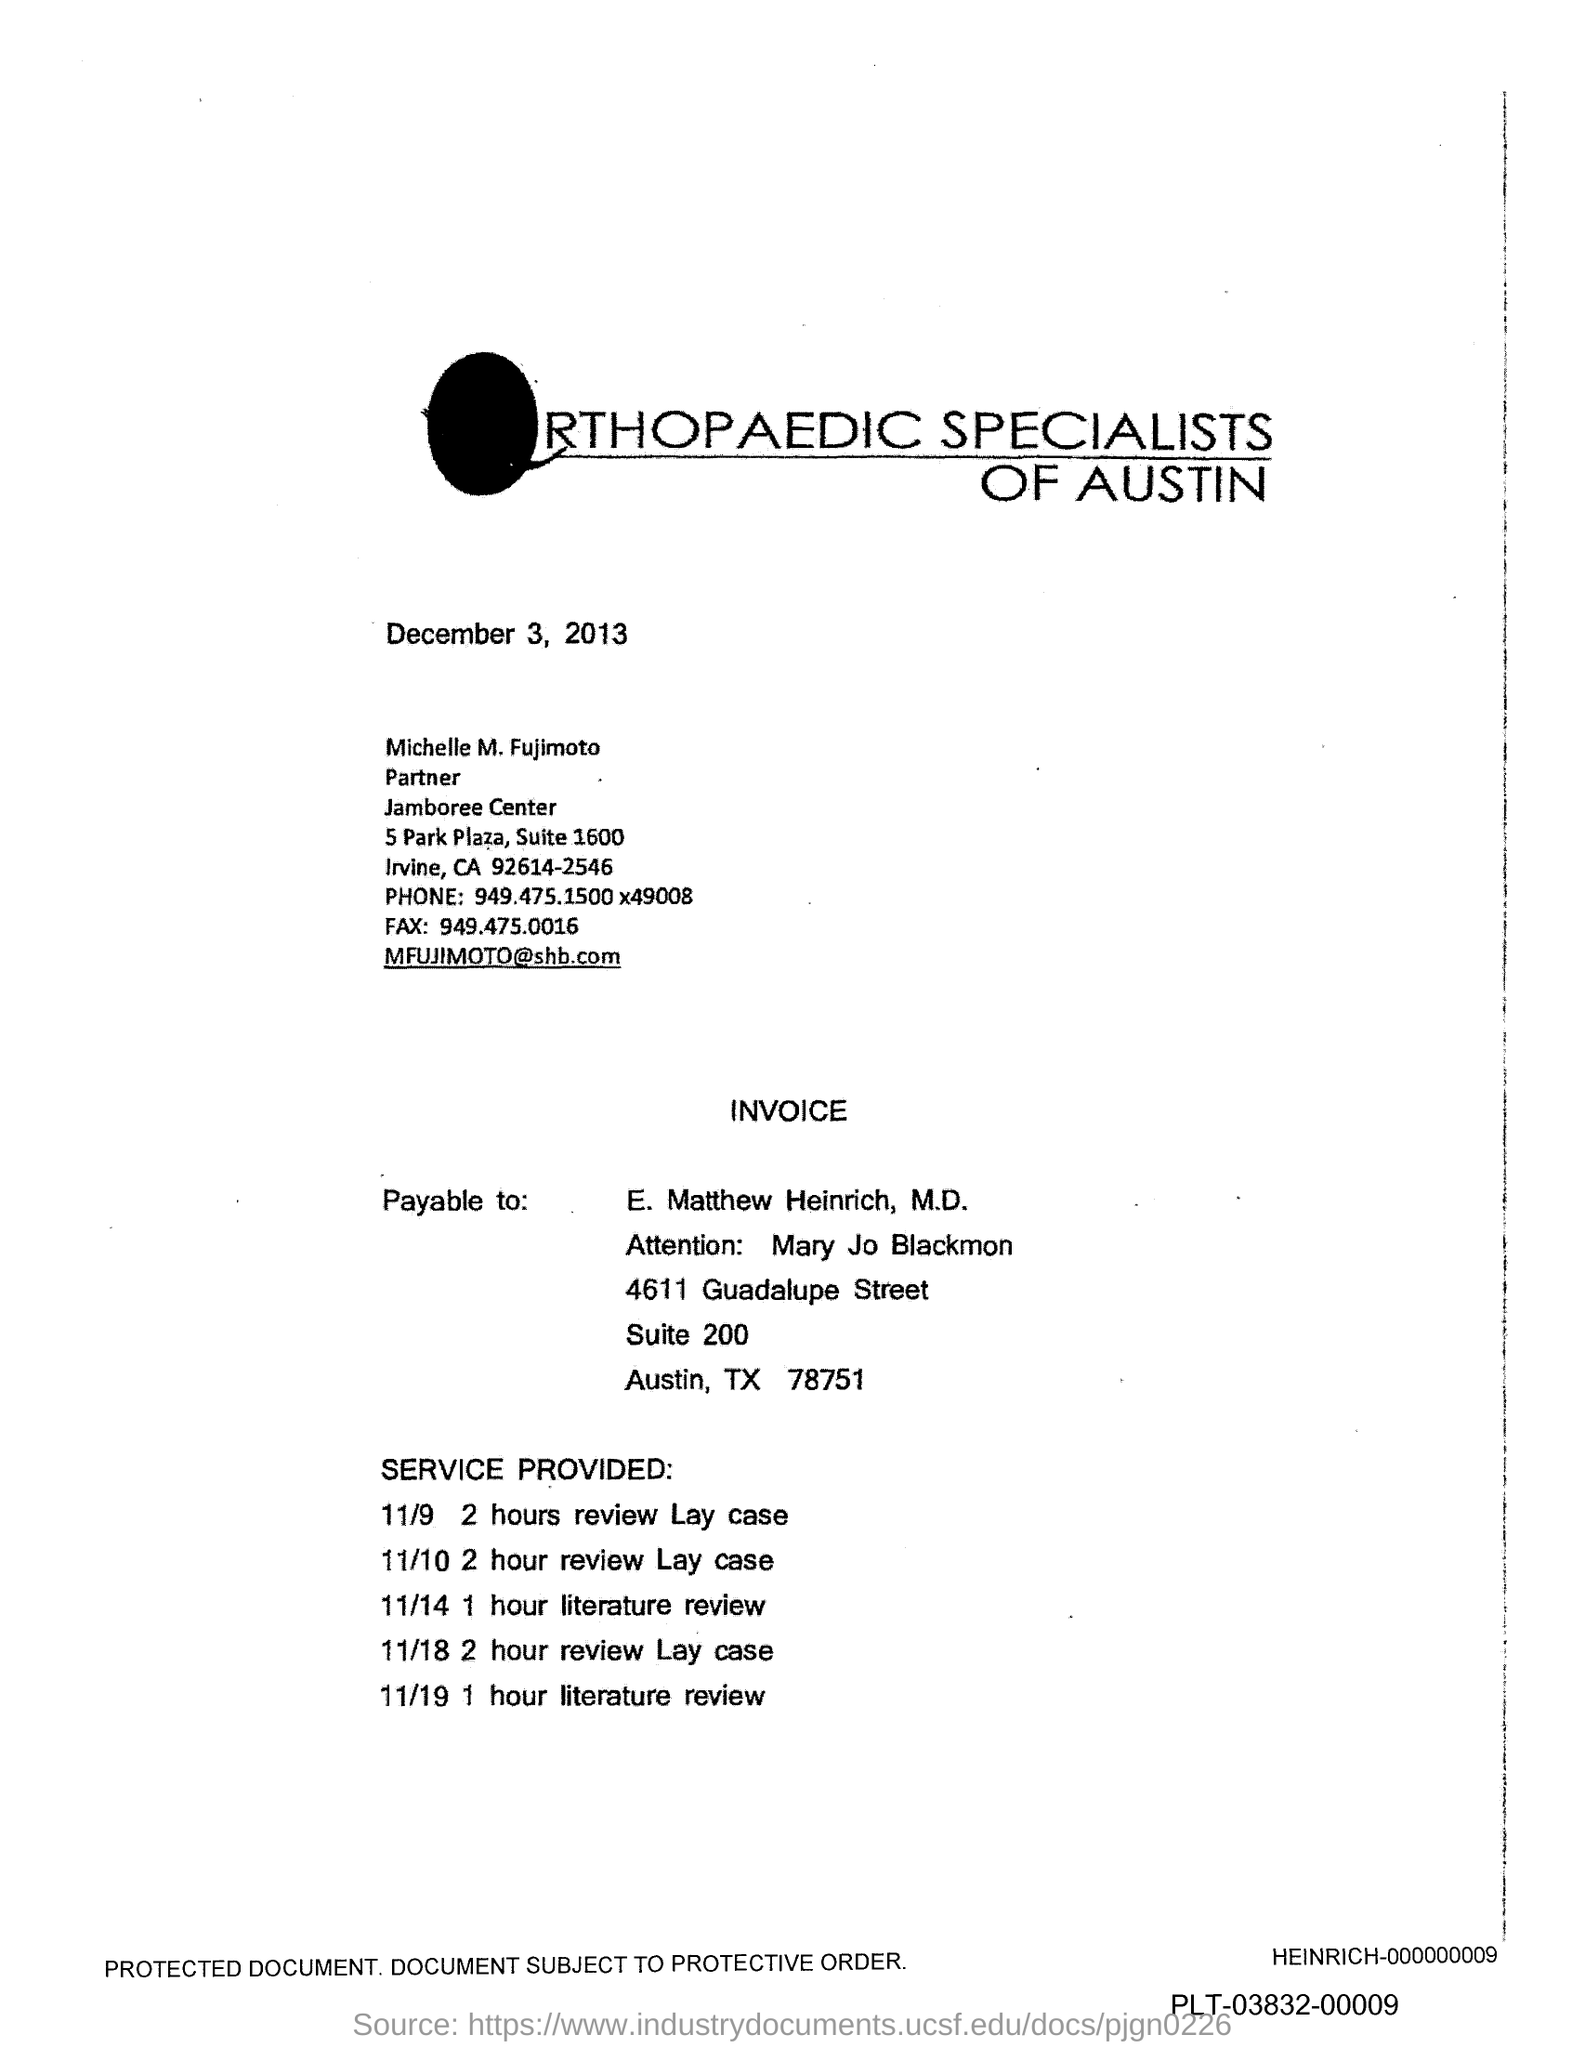Outline some significant characteristics in this image. The email address mentioned in the document is [MFUJIMOTO@shb.com](mailto:MFUJIMOTO@shb.com). The fax number mentioned in the document is 949.475.0016... 